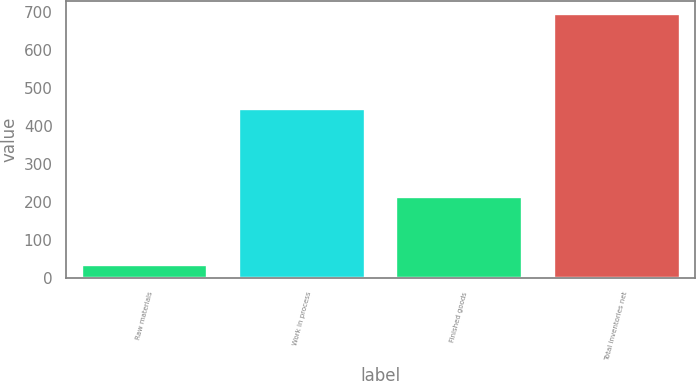Convert chart. <chart><loc_0><loc_0><loc_500><loc_500><bar_chart><fcel>Raw materials<fcel>Work in process<fcel>Finished goods<fcel>Total inventories net<nl><fcel>34<fcel>446<fcel>214<fcel>694<nl></chart> 